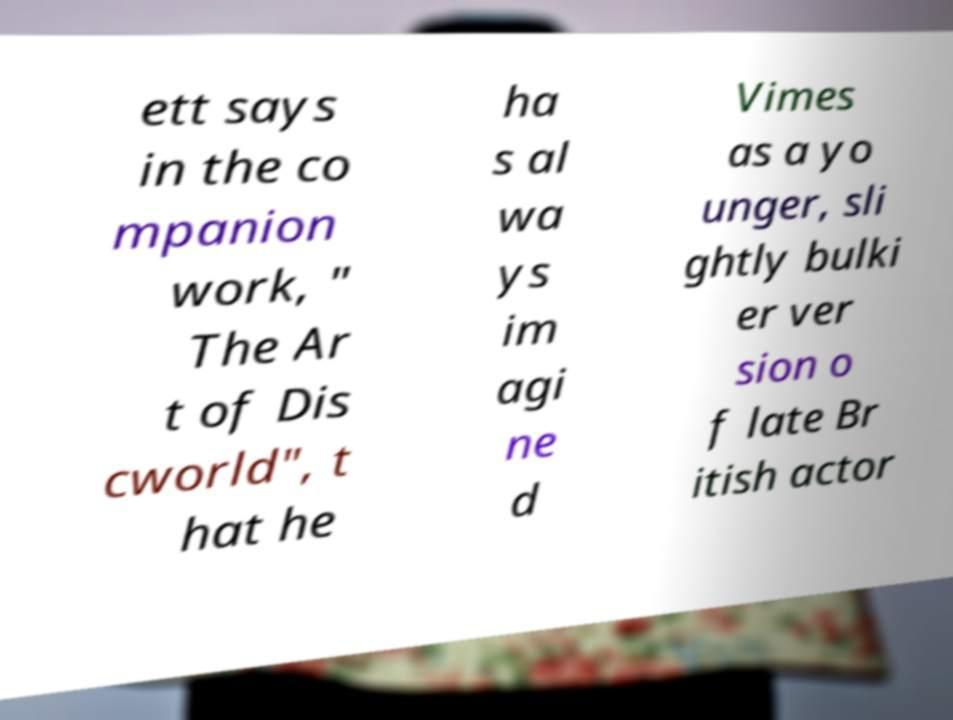For documentation purposes, I need the text within this image transcribed. Could you provide that? ett says in the co mpanion work, " The Ar t of Dis cworld", t hat he ha s al wa ys im agi ne d Vimes as a yo unger, sli ghtly bulki er ver sion o f late Br itish actor 